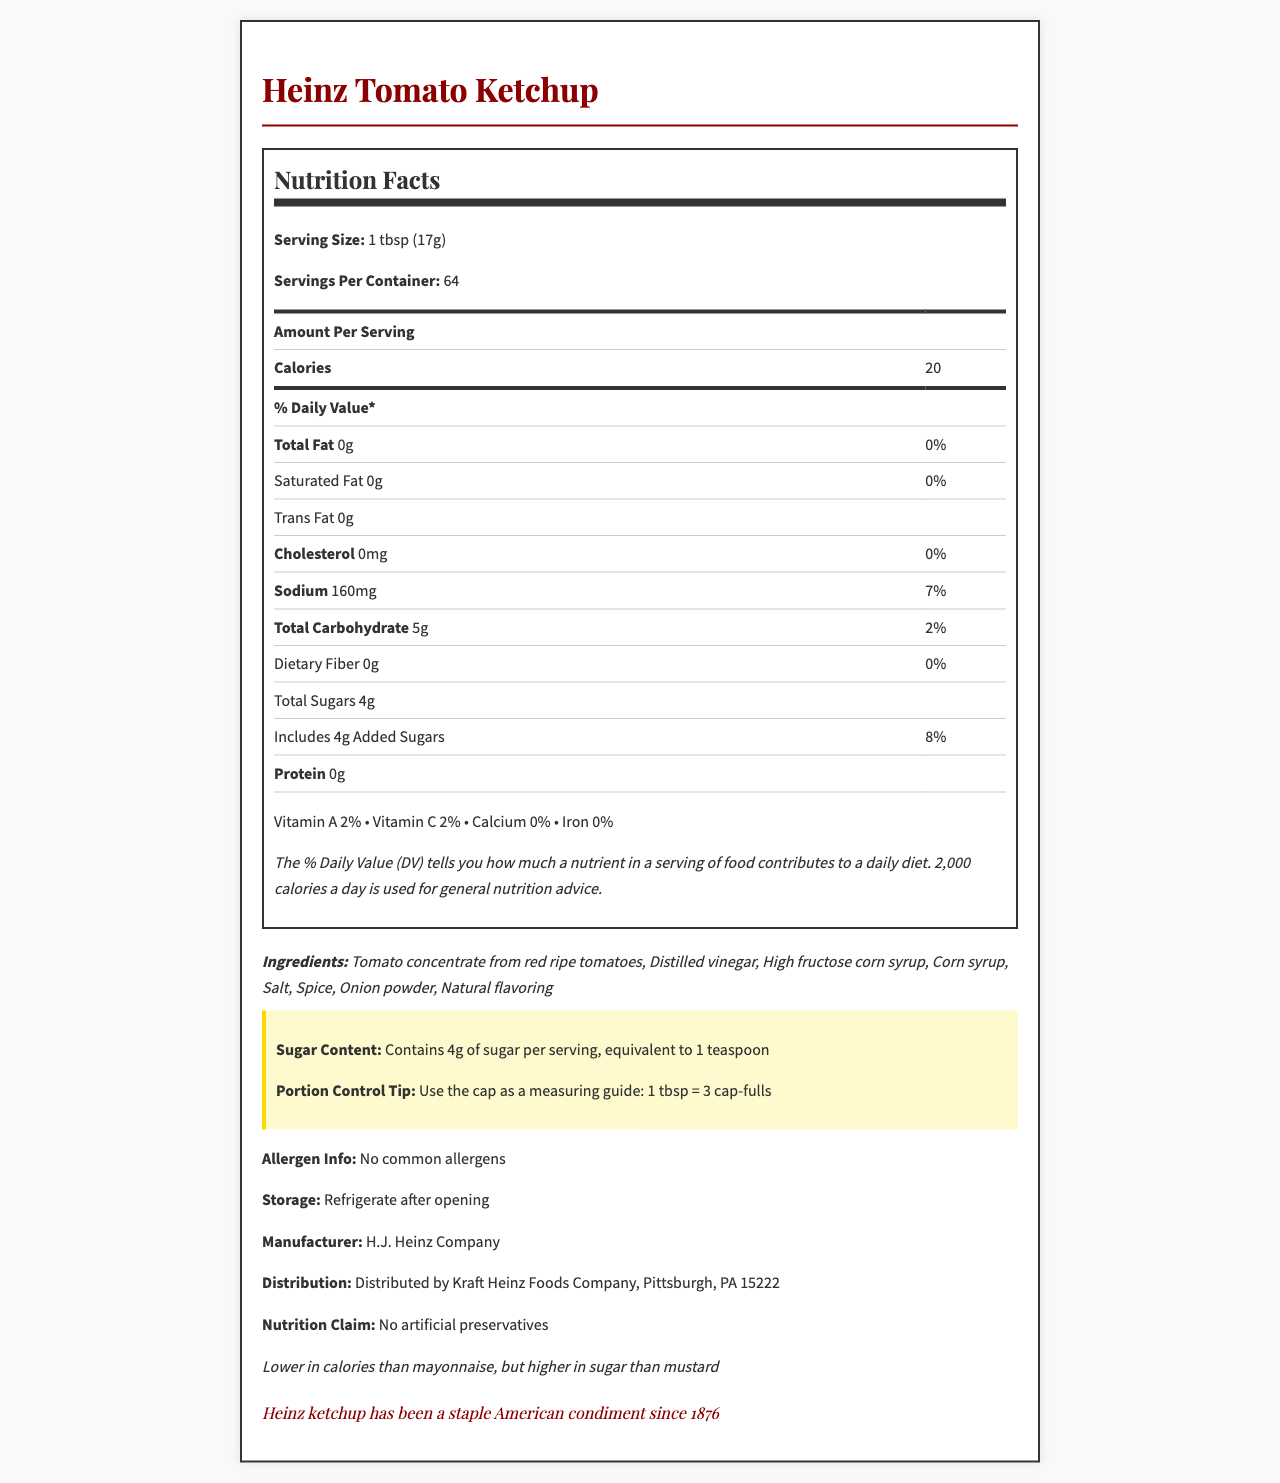What is the serving size of Heinz Tomato Ketchup? The serving size is explicitly stated at the beginning of the nutrition label section.
Answer: 1 tbsp (17g) How many calories are there per serving? The calories per serving are listed in the nutrition facts table.
Answer: 20 How many grams of total sugars are in one serving? The total sugars per serving are shown in the nutrition facts label.
Answer: 4g What is the sodium content per serving? The sodium content is listed next to its respective label in the nutrition facts.
Answer: 160mg Does Heinz Tomato Ketchup contain any common allergens? The allergen information states "No common allergens."
Answer: No Use the cap as a measuring guide: How many cap-fulls equal one tbsp? The portion control tip indicates that 1 tbsp is equal to 3 cap-fulls.
Answer: 3 cap-fulls How does the sugar content of Heinz Ketchup compare to other condiments? A. Higher than mayonnaise B. Higher than mustard C. Lower than mayonnaise D. Both A and B The comparison section indicates that ketchup is lower in calories than mayonnaise but higher in sugar than mustard.
Answer: D What percentage of the daily value of sodium does one serving provide? A. 2% B. 8% C. 7% D. 10% The nutrition facts state that the sodium content per serving is 7% of the daily value.
Answer: C Which vitamin has a 2% daily value in Heinz Tomato Ketchup? A. Vitamin A B. Vitamin C C. Both D. Neither Both vitamin A and vitamin C have a 2% daily value listed in the nutrition facts.
Answer: C Is there any fiber in one serving of Heinz Tomato Ketchup? The nutritional information shows 0g of dietary fiber.
Answer: No What additional information is provided about the sugar content? The highlight section emphasizes the sugar content with this information.
Answer: Contains 4g of sugar per serving, equivalent to 1 teaspoon Could you determine the number of calories from fat in a serving? There is no information provided about the calories from fat.
Answer: Cannot be determined Summarize the main features and historical context of Heinz Tomato Ketchup from the document. This summary covers the key nutritional information, portion control tips, and historical context provided in the document.
Answer: Heinz Tomato Ketchup provides 20 calories per 1 tbsp (17g) serving, contains 4g of total sugars, and has no common allergens. It is lower in calories than mayonnaise but higher in sugar than mustard. Heinz ketchup has been a staple American condiment since 1876. It claims "No artificial preservatives," and advises portion control through cap-fulls measurement. 